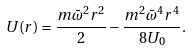<formula> <loc_0><loc_0><loc_500><loc_500>U ( r ) = \frac { m \bar { \omega } ^ { 2 } r ^ { 2 } } { 2 } - \frac { m ^ { 2 } \bar { \omega } ^ { 4 } r ^ { 4 } } { 8 U _ { 0 } } .</formula> 